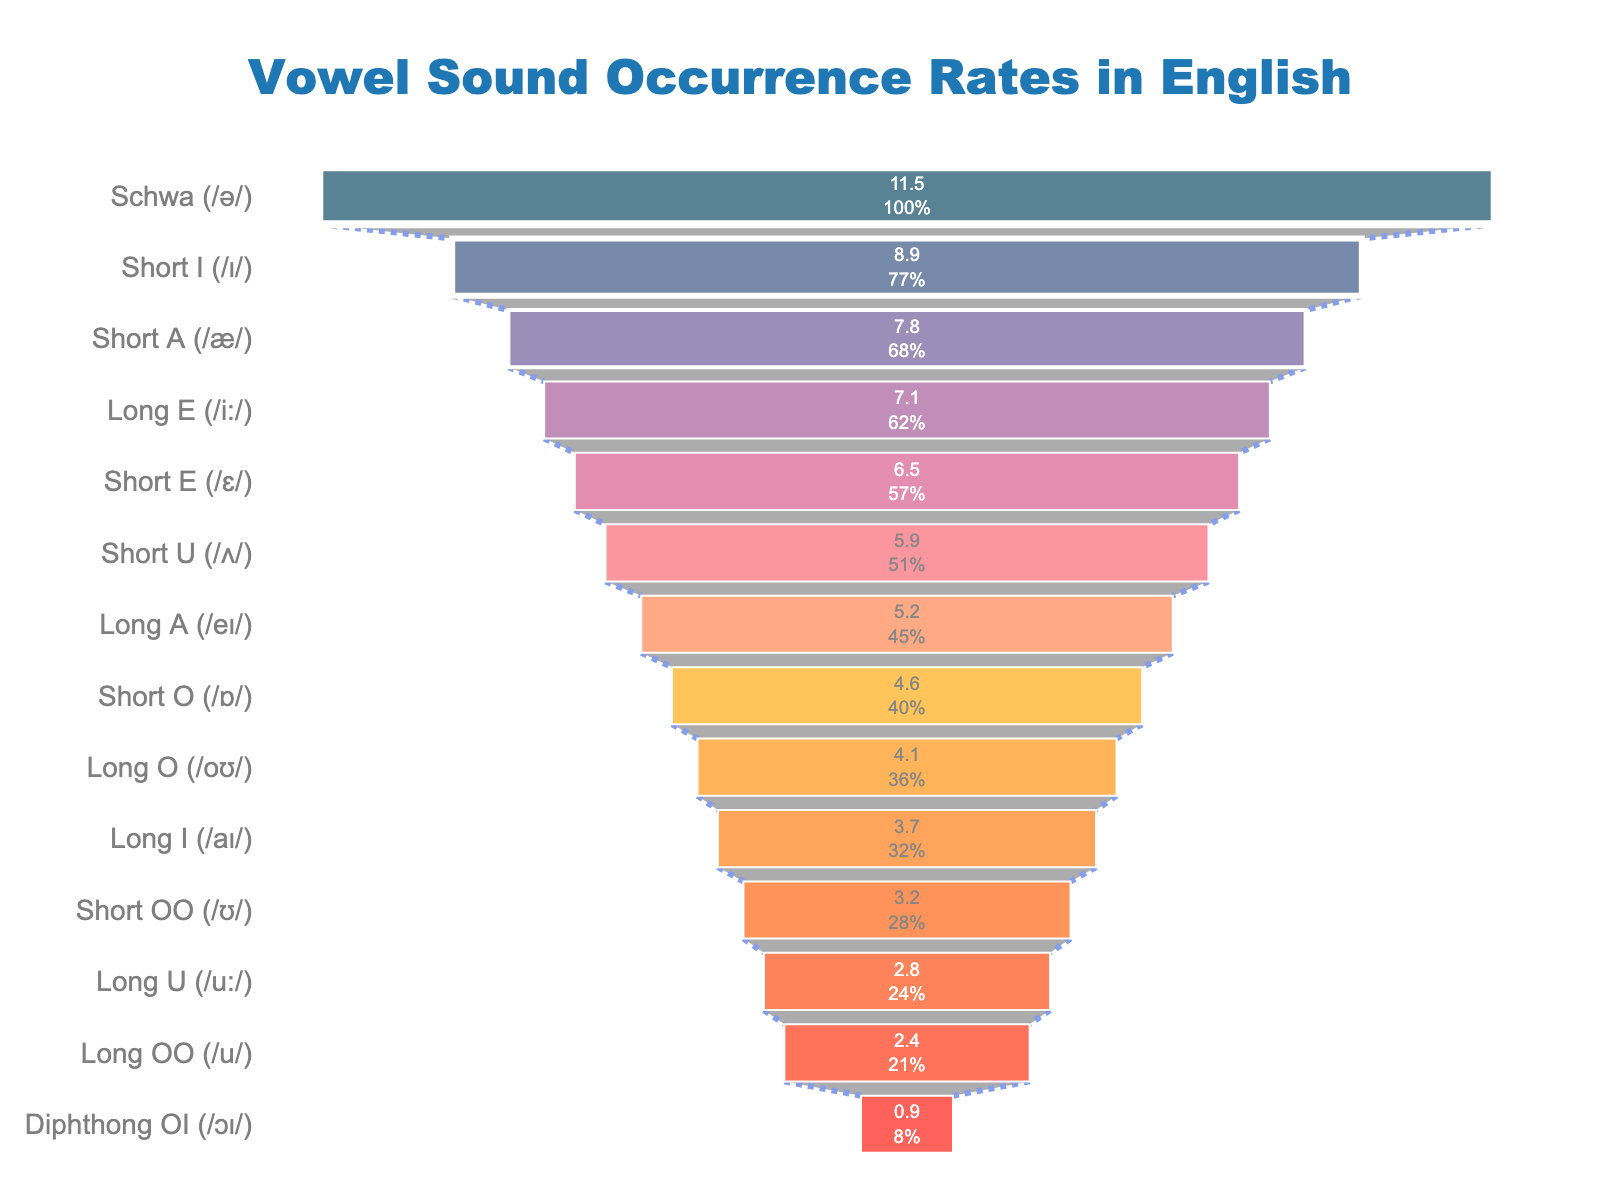What's the title of the figure? The title of the figure is typically found at the top of the chart. It provides an overview of what the chart represents. In this case, the title reads "Vowel Sound Occurrence Rates in English".
Answer: Vowel Sound Occurrence Rates in English How many vowel sounds are represented in the figure? By counting the number of distinct bars or segments in the funnel chart, one can determine the number of vowel sounds represented. Each segment corresponds to a vowel sound listed in the data.
Answer: 14 Which vowel sound has the highest occurrence rate? The vowel sound with the highest occurrence rate is shown at the widest part (top) of the funnel chart. According to the chart, the "Schwa (/ə/)" has the highest occurrence rate.
Answer: Schwa (/ə/) What is the occurrence rate of the "Short E (/ɛ/)" sound? To find this, locate the "Short E (/ɛ/)" segment on the funnel chart and read the corresponding value for the occurrence rate from the data or labels.
Answer: 6.5 What's the total occurrence rate for the top three most common vowel sounds? Add the occurrence rates of the top three most common vowel sounds. According to the chart, these are: Schwa (/ə/) with 11.5, Short I (/ɪ/) with 8.9, and Short A (/æ/) with 7.8. The total is 11.5 + 8.9 + 7.8 = 28.2.
Answer: 28.2 Which vowel sound is more common, "Long E (/i:/)" or "Short O (/ɒ/)"? Compare the occurrence rates of the "Long E (/i:/)" and "Short O (/ɒ/)". The funnel chart shows "Long E (/i:/)" with an occurrence rate of 7.1 and "Short O (/ɒ/)" with an occurrence rate of 4.6. Therefore, "Long E (/i:/)" is more common.
Answer: Long E (/i:/) What is the difference in occurrence rate between "Long U (/u:/)" and "Long OO (/u/)"? Find the occurrence rates of both vowel sounds and subtract the smaller from the larger. "Long U (/u:/)" has an occurrence rate of 2.8 and "Long OO (/u/)" has 2.4. The difference is 2.8 - 2.4 = 0.4.
Answer: 0.4 What is the least common vowel sound? The least common vowel sound is shown at the narrowest part (bottom) of the funnel chart. According to the chart, the "Diphthong OI (/ɔɪ/)" has the lowest occurrence rate of 0.9.
Answer: Diphthong OI (/ɔɪ/) Which sounds have occurrence rates greater than 5? Identify all segments in the funnel chart where the occurrence rate exceeds 5. These are: Schwa (/ə/), Short I (/ɪ/), Short A (/æ/), Long E (/i:/), Short E (/ɛ/), and Short U (/ʌ/).
Answer: Schwa (/ə/), Short I (/ɪ/), Short A (/æ/), Long E (/i:/), Short E (/ɛ/), Short U (/ʌ/) How is the data sorted in the figure? The data is sorted in descending order of occurrence rate, from the most common vowel sound at the top to the least common vowel sound at the bottom.
Answer: Descending order of occurrence rate 